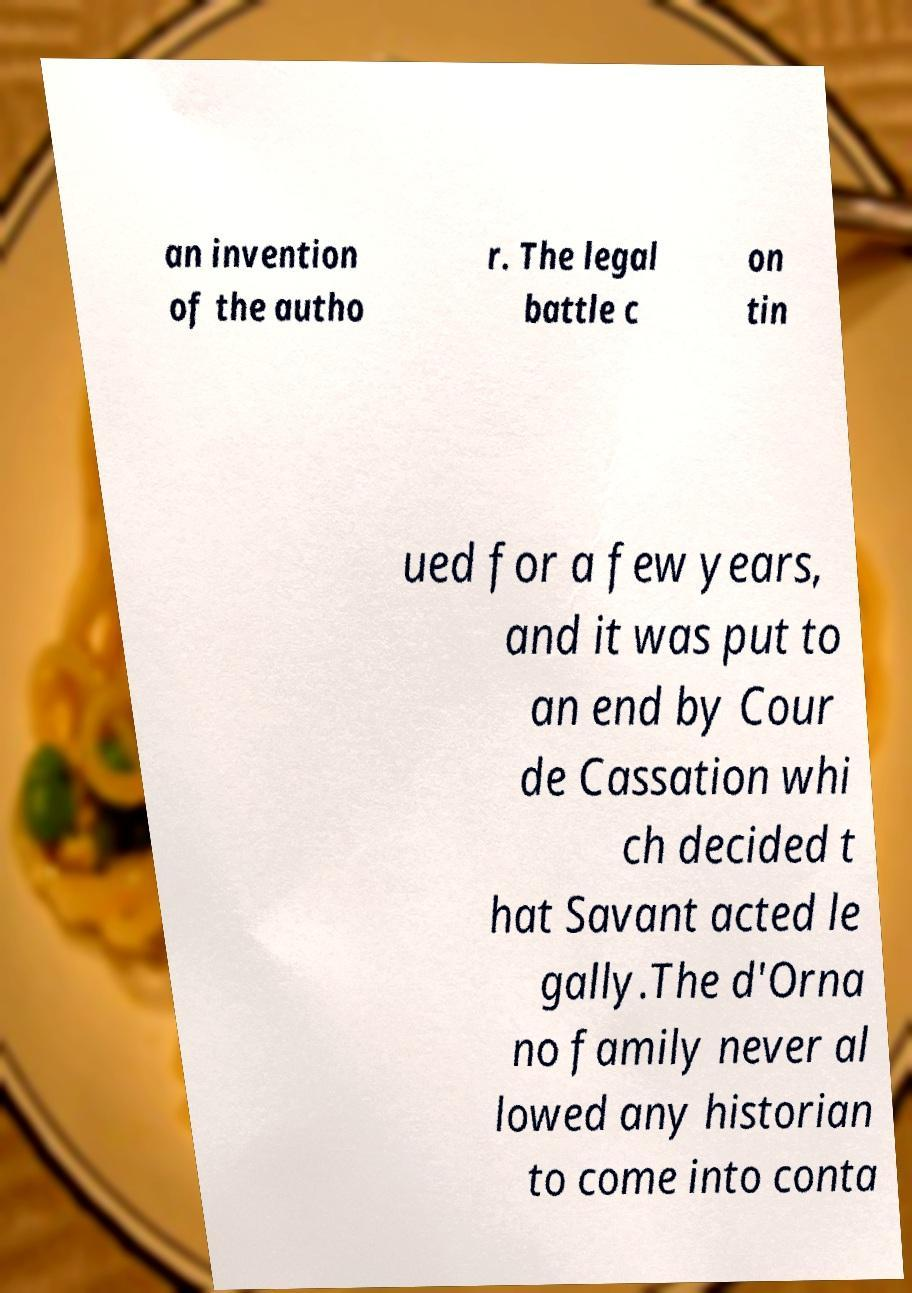What messages or text are displayed in this image? I need them in a readable, typed format. an invention of the autho r. The legal battle c on tin ued for a few years, and it was put to an end by Cour de Cassation whi ch decided t hat Savant acted le gally.The d'Orna no family never al lowed any historian to come into conta 